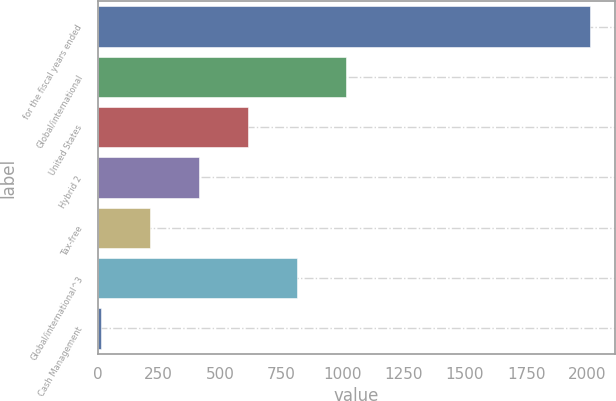Convert chart to OTSL. <chart><loc_0><loc_0><loc_500><loc_500><bar_chart><fcel>for the fiscal years ended<fcel>Global/international<fcel>United States<fcel>Hybrid 2<fcel>Tax-free<fcel>Global/international^3<fcel>Cash Management<nl><fcel>2013<fcel>1013<fcel>613<fcel>413<fcel>213<fcel>813<fcel>13<nl></chart> 